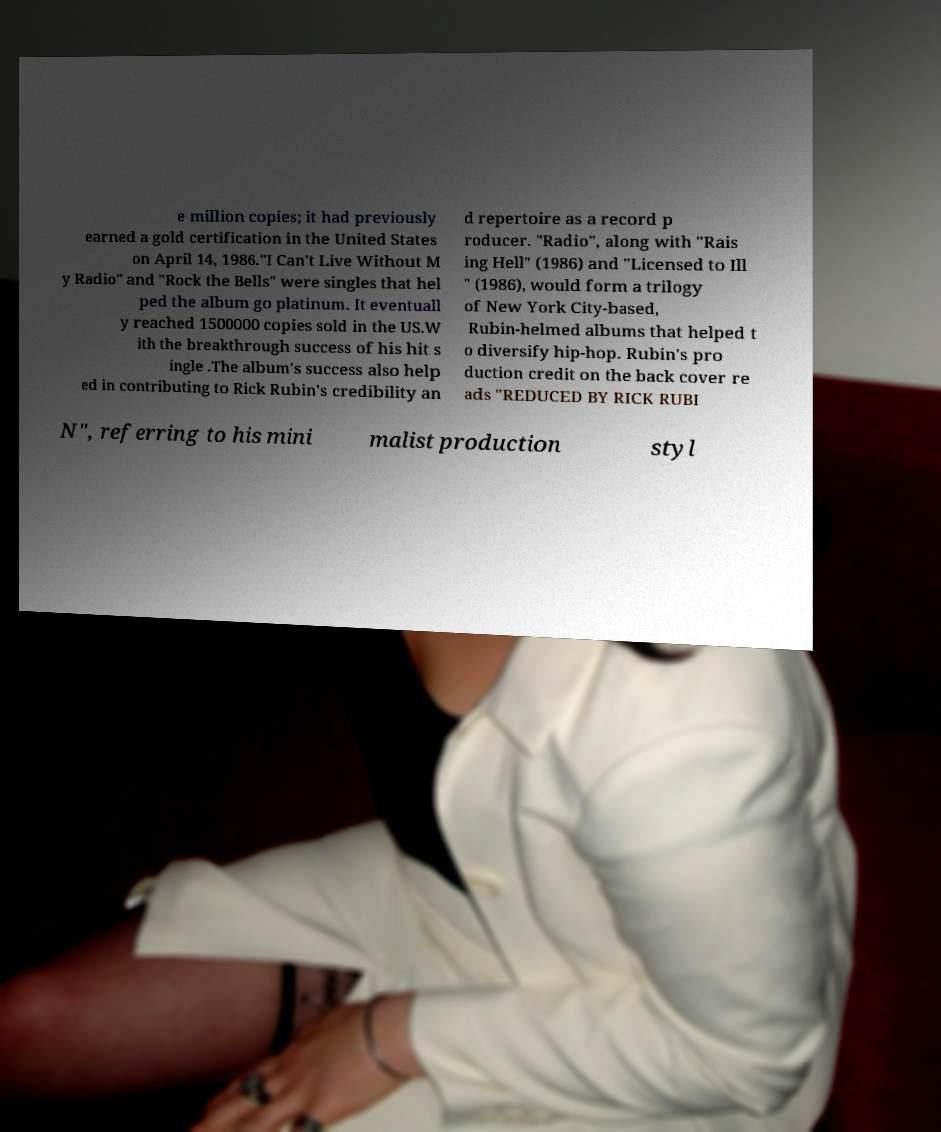Could you assist in decoding the text presented in this image and type it out clearly? e million copies; it had previously earned a gold certification in the United States on April 14, 1986."I Can't Live Without M y Radio" and "Rock the Bells" were singles that hel ped the album go platinum. It eventuall y reached 1500000 copies sold in the US.W ith the breakthrough success of his hit s ingle .The album's success also help ed in contributing to Rick Rubin's credibility an d repertoire as a record p roducer. "Radio", along with "Rais ing Hell" (1986) and "Licensed to Ill " (1986), would form a trilogy of New York City-based, Rubin-helmed albums that helped t o diversify hip-hop. Rubin's pro duction credit on the back cover re ads "REDUCED BY RICK RUBI N", referring to his mini malist production styl 